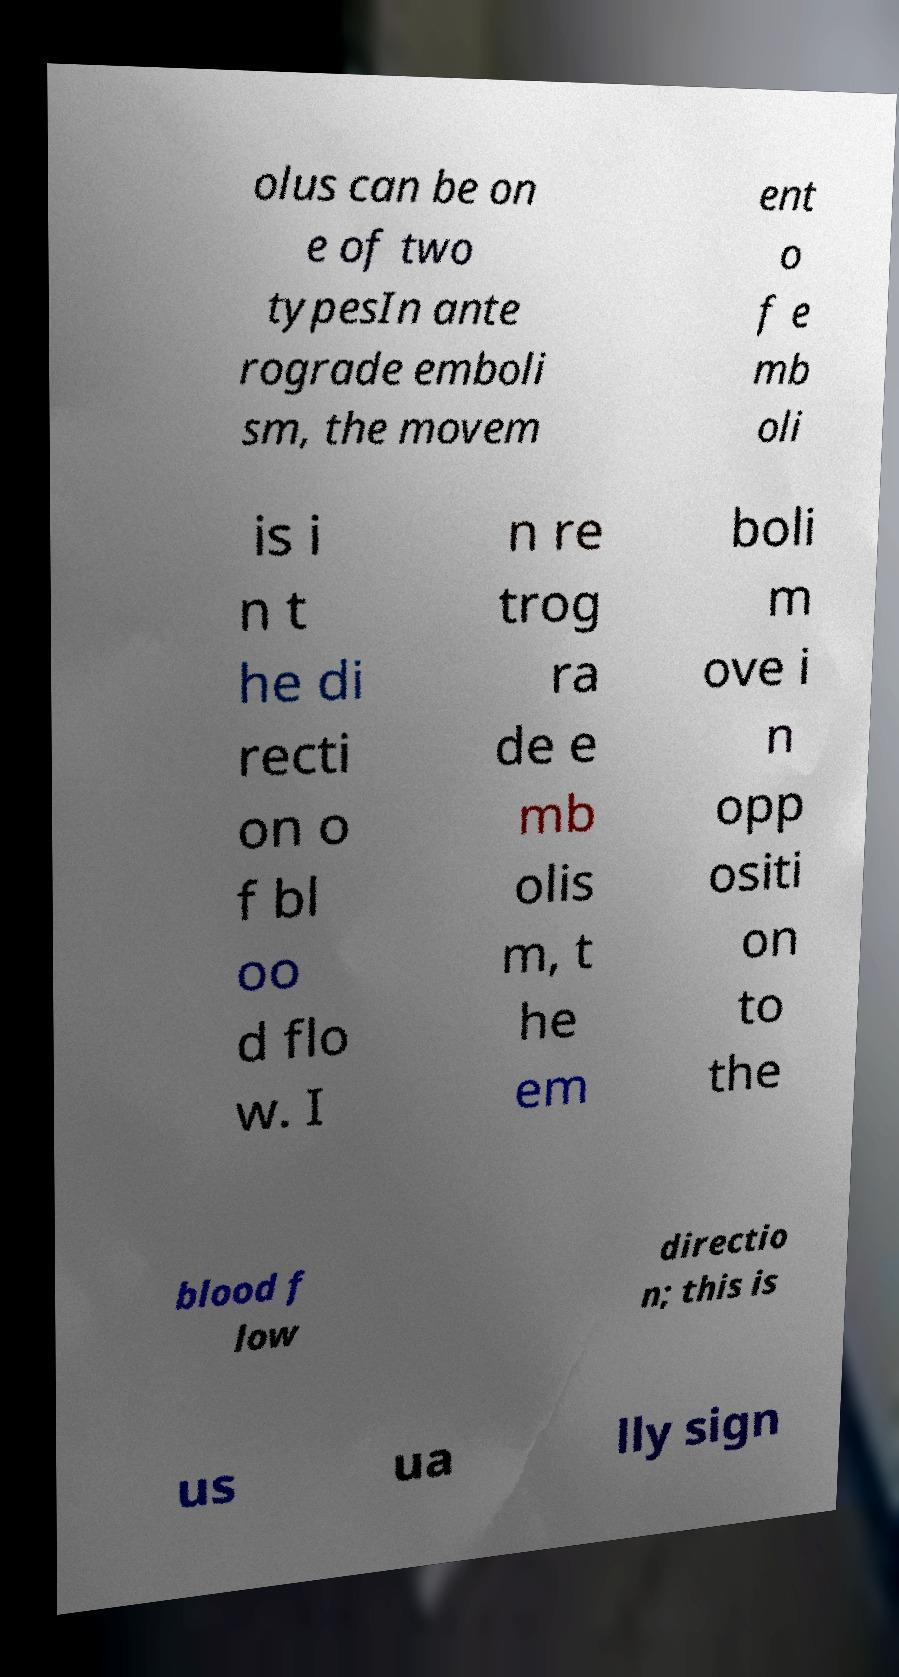Could you assist in decoding the text presented in this image and type it out clearly? olus can be on e of two typesIn ante rograde emboli sm, the movem ent o f e mb oli is i n t he di recti on o f bl oo d flo w. I n re trog ra de e mb olis m, t he em boli m ove i n opp ositi on to the blood f low directio n; this is us ua lly sign 